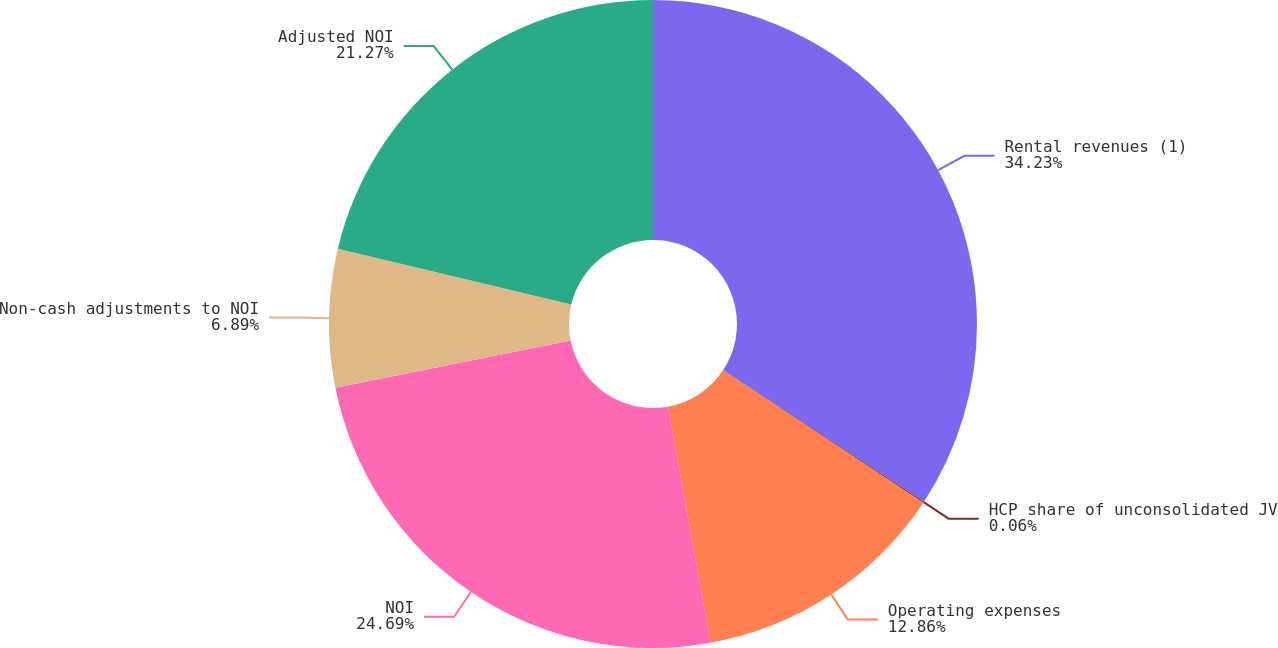Convert chart. <chart><loc_0><loc_0><loc_500><loc_500><pie_chart><fcel>Rental revenues (1)<fcel>HCP share of unconsolidated JV<fcel>Operating expenses<fcel>NOI<fcel>Non-cash adjustments to NOI<fcel>Adjusted NOI<nl><fcel>34.24%<fcel>0.06%<fcel>12.86%<fcel>24.69%<fcel>6.89%<fcel>21.27%<nl></chart> 